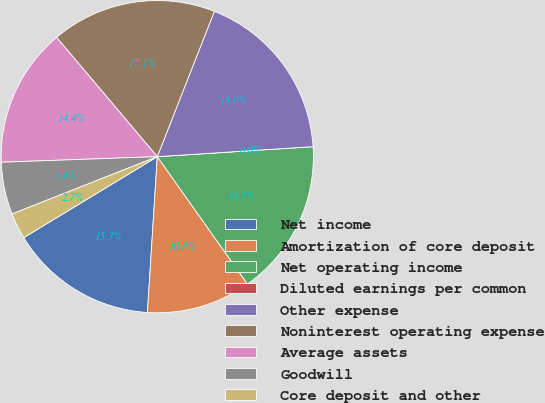<chart> <loc_0><loc_0><loc_500><loc_500><pie_chart><fcel>Net income<fcel>Amortization of core deposit<fcel>Net operating income<fcel>Diluted earnings per common<fcel>Other expense<fcel>Noninterest operating expense<fcel>Average assets<fcel>Goodwill<fcel>Core deposit and other<nl><fcel>15.32%<fcel>10.81%<fcel>16.22%<fcel>0.0%<fcel>18.02%<fcel>17.12%<fcel>14.41%<fcel>5.41%<fcel>2.7%<nl></chart> 